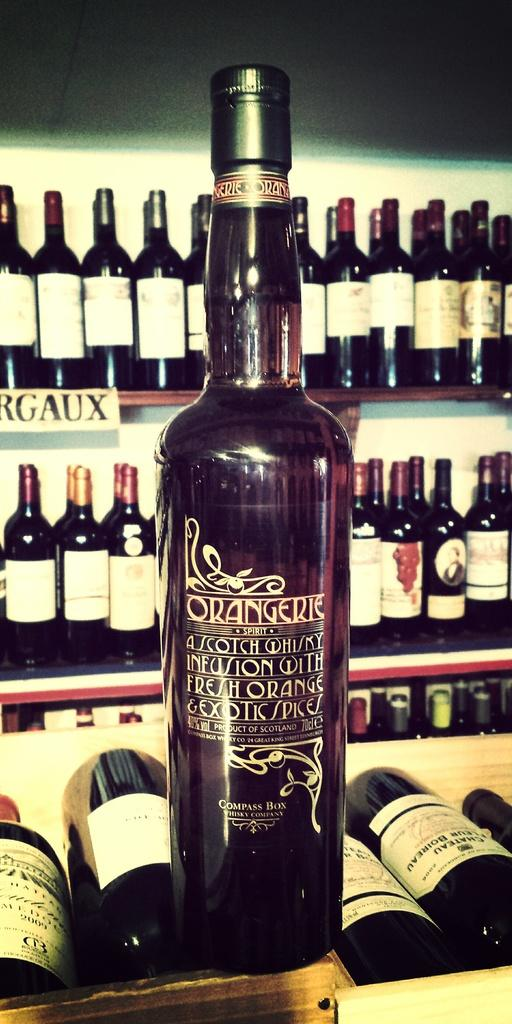<image>
Share a concise interpretation of the image provided. 'Orangerie' is a Scotch Whiskey Infusion with fresh orange and exotic spices from Scotland. 